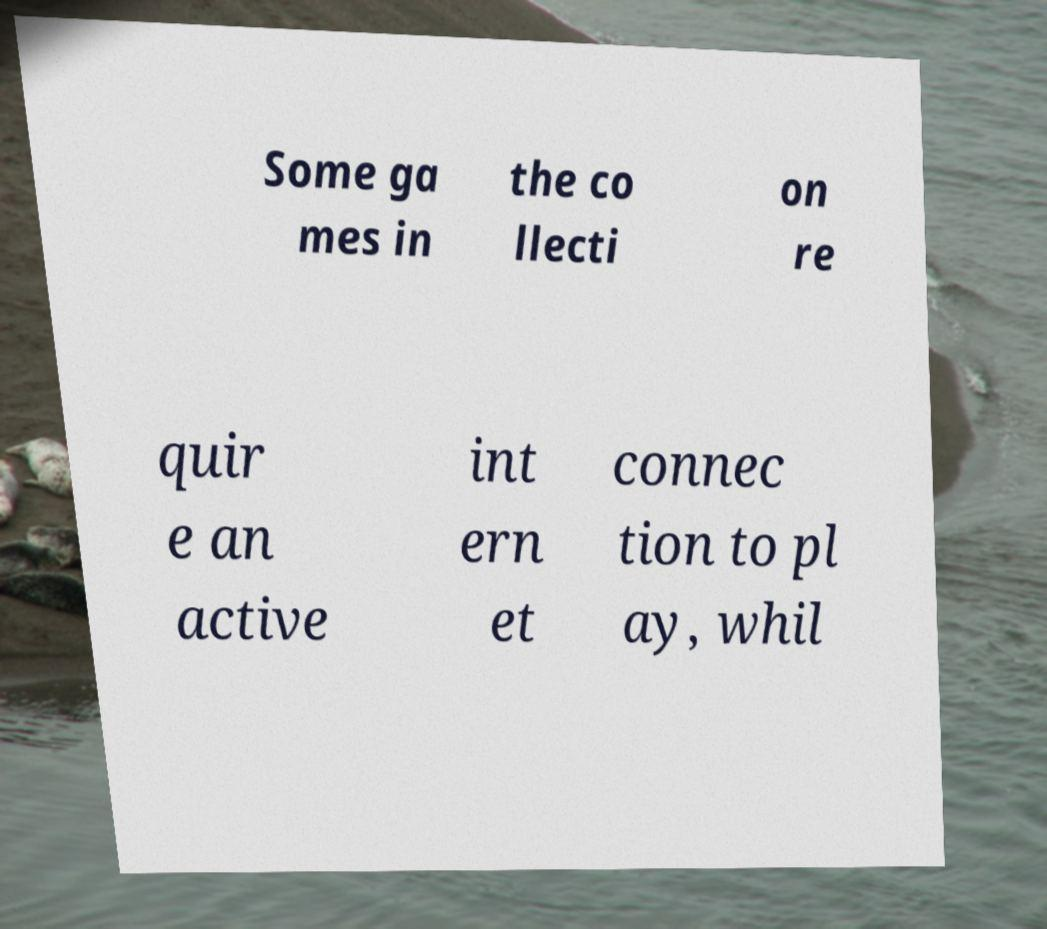Could you extract and type out the text from this image? Some ga mes in the co llecti on re quir e an active int ern et connec tion to pl ay, whil 